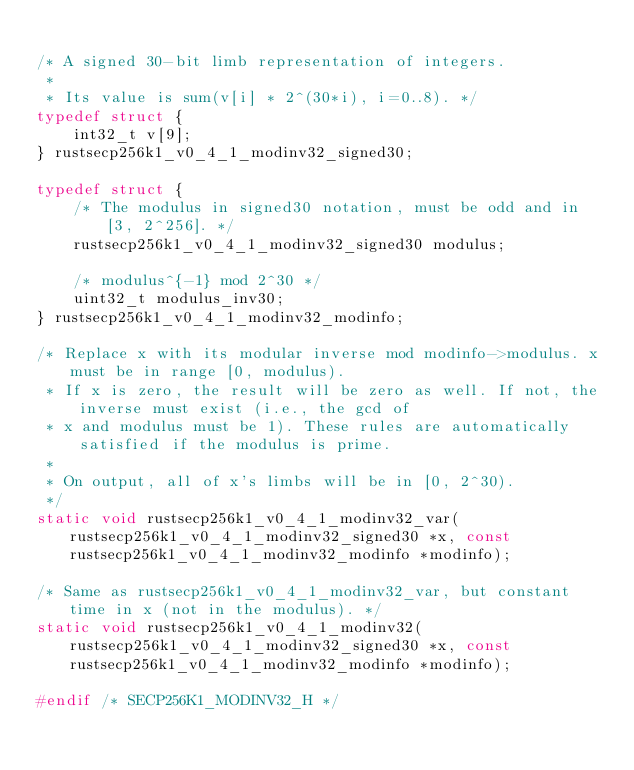Convert code to text. <code><loc_0><loc_0><loc_500><loc_500><_C_>
/* A signed 30-bit limb representation of integers.
 *
 * Its value is sum(v[i] * 2^(30*i), i=0..8). */
typedef struct {
    int32_t v[9];
} rustsecp256k1_v0_4_1_modinv32_signed30;

typedef struct {
    /* The modulus in signed30 notation, must be odd and in [3, 2^256]. */
    rustsecp256k1_v0_4_1_modinv32_signed30 modulus;

    /* modulus^{-1} mod 2^30 */
    uint32_t modulus_inv30;
} rustsecp256k1_v0_4_1_modinv32_modinfo;

/* Replace x with its modular inverse mod modinfo->modulus. x must be in range [0, modulus).
 * If x is zero, the result will be zero as well. If not, the inverse must exist (i.e., the gcd of
 * x and modulus must be 1). These rules are automatically satisfied if the modulus is prime.
 *
 * On output, all of x's limbs will be in [0, 2^30).
 */
static void rustsecp256k1_v0_4_1_modinv32_var(rustsecp256k1_v0_4_1_modinv32_signed30 *x, const rustsecp256k1_v0_4_1_modinv32_modinfo *modinfo);

/* Same as rustsecp256k1_v0_4_1_modinv32_var, but constant time in x (not in the modulus). */
static void rustsecp256k1_v0_4_1_modinv32(rustsecp256k1_v0_4_1_modinv32_signed30 *x, const rustsecp256k1_v0_4_1_modinv32_modinfo *modinfo);

#endif /* SECP256K1_MODINV32_H */
</code> 